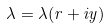<formula> <loc_0><loc_0><loc_500><loc_500>\lambda = \lambda ( r + i y )</formula> 